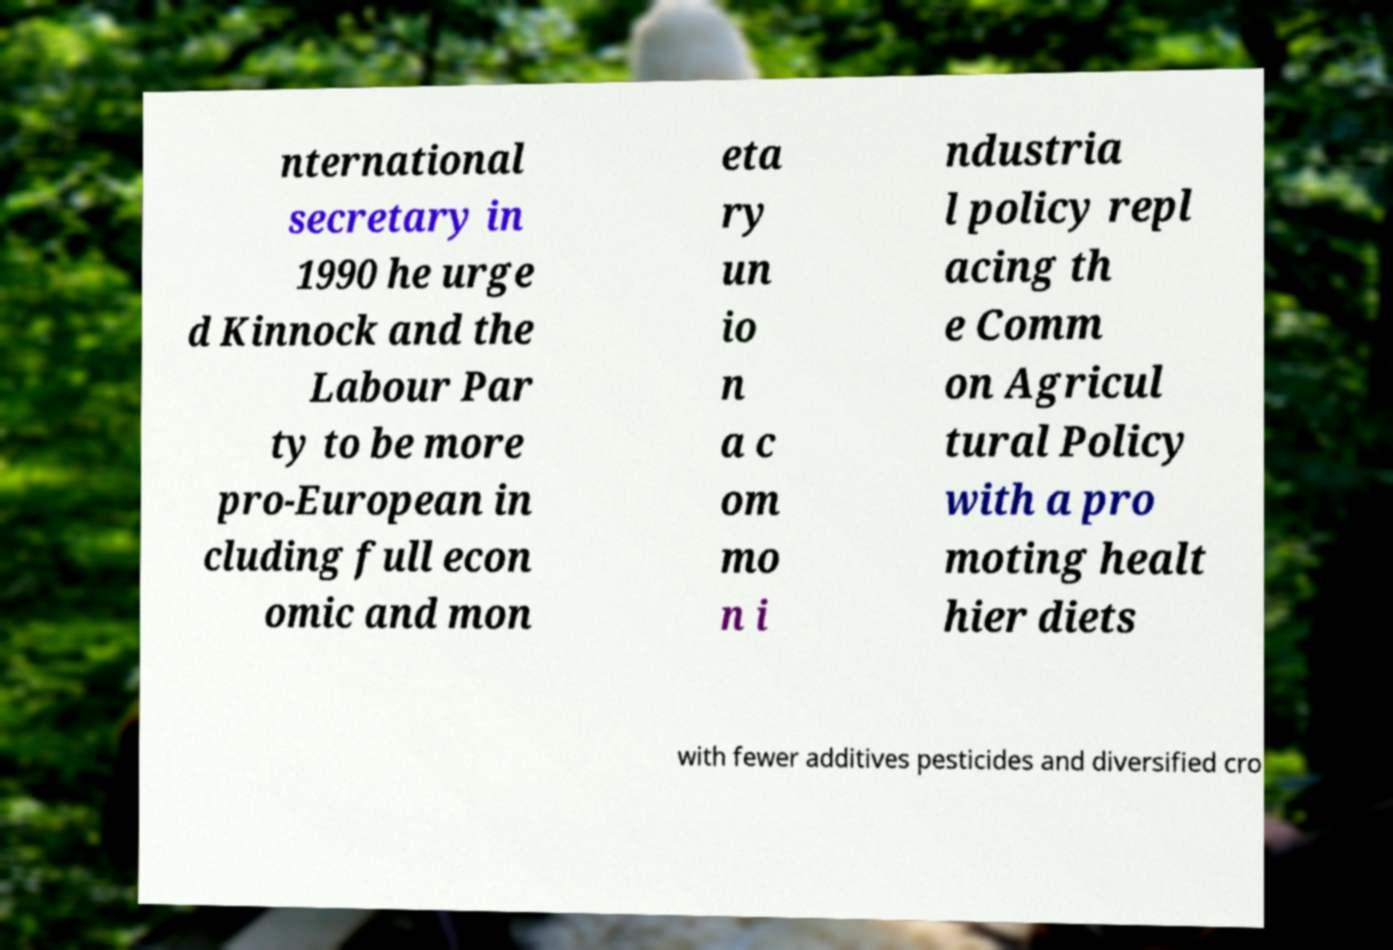Please identify and transcribe the text found in this image. nternational secretary in 1990 he urge d Kinnock and the Labour Par ty to be more pro-European in cluding full econ omic and mon eta ry un io n a c om mo n i ndustria l policy repl acing th e Comm on Agricul tural Policy with a pro moting healt hier diets with fewer additives pesticides and diversified cro 